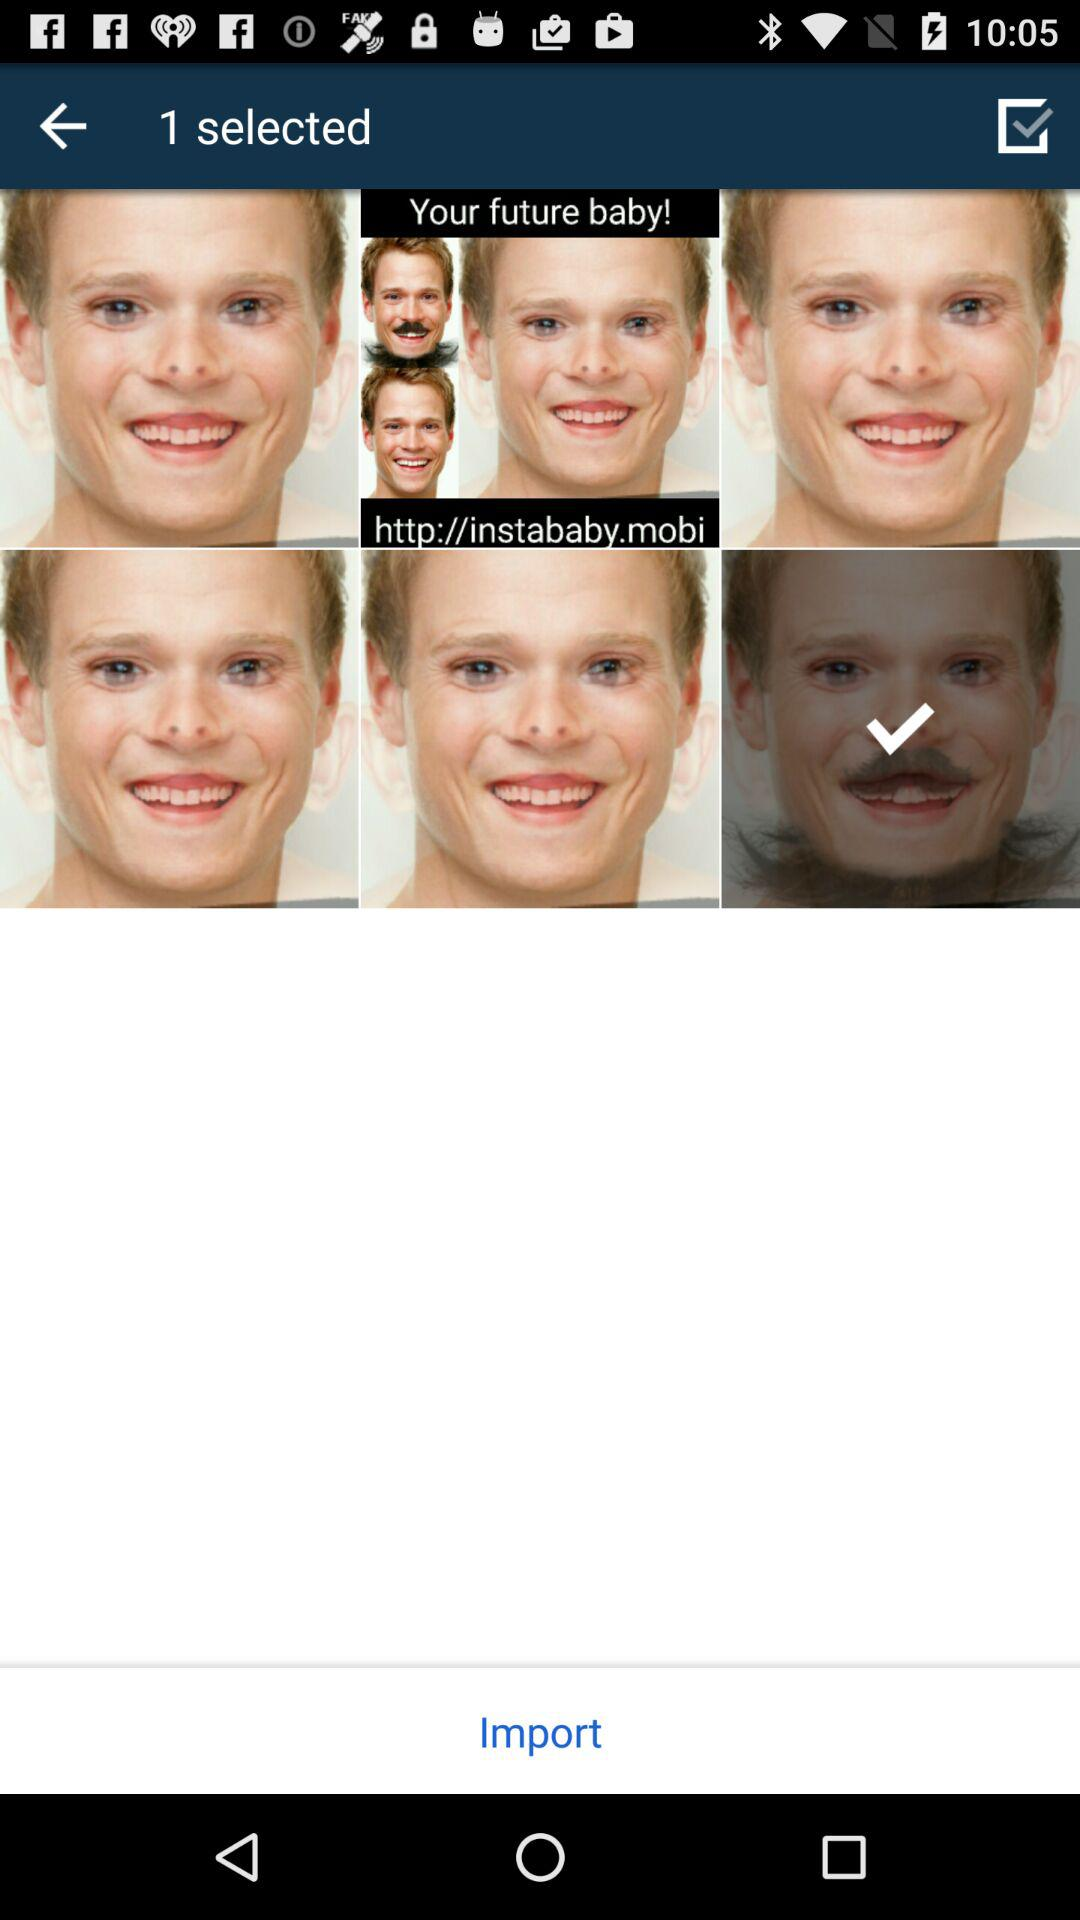What is the count of selected images? The count of selected images is 1. 